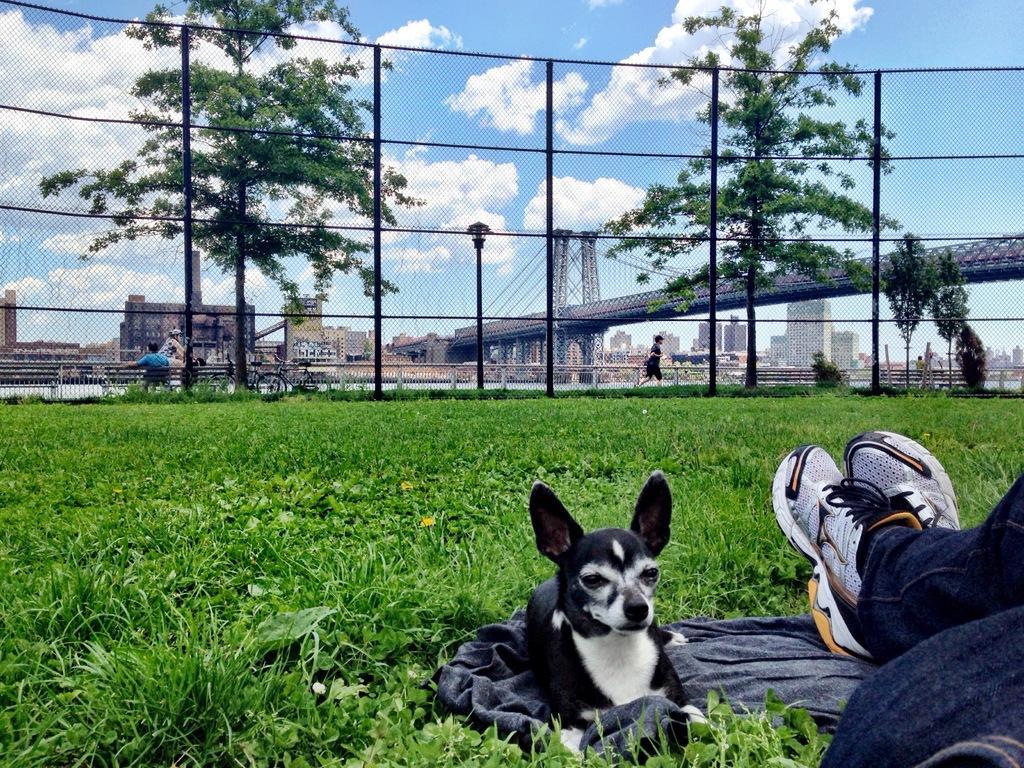In one or two sentences, can you explain what this image depicts? In this image I can see the person's legs and I can also see the dog in black and white color. In the background I can see the railing, few trees in green color, light poles, few people, buildings and the sky is in blue and white color. 